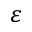<formula> <loc_0><loc_0><loc_500><loc_500>\varepsilon</formula> 